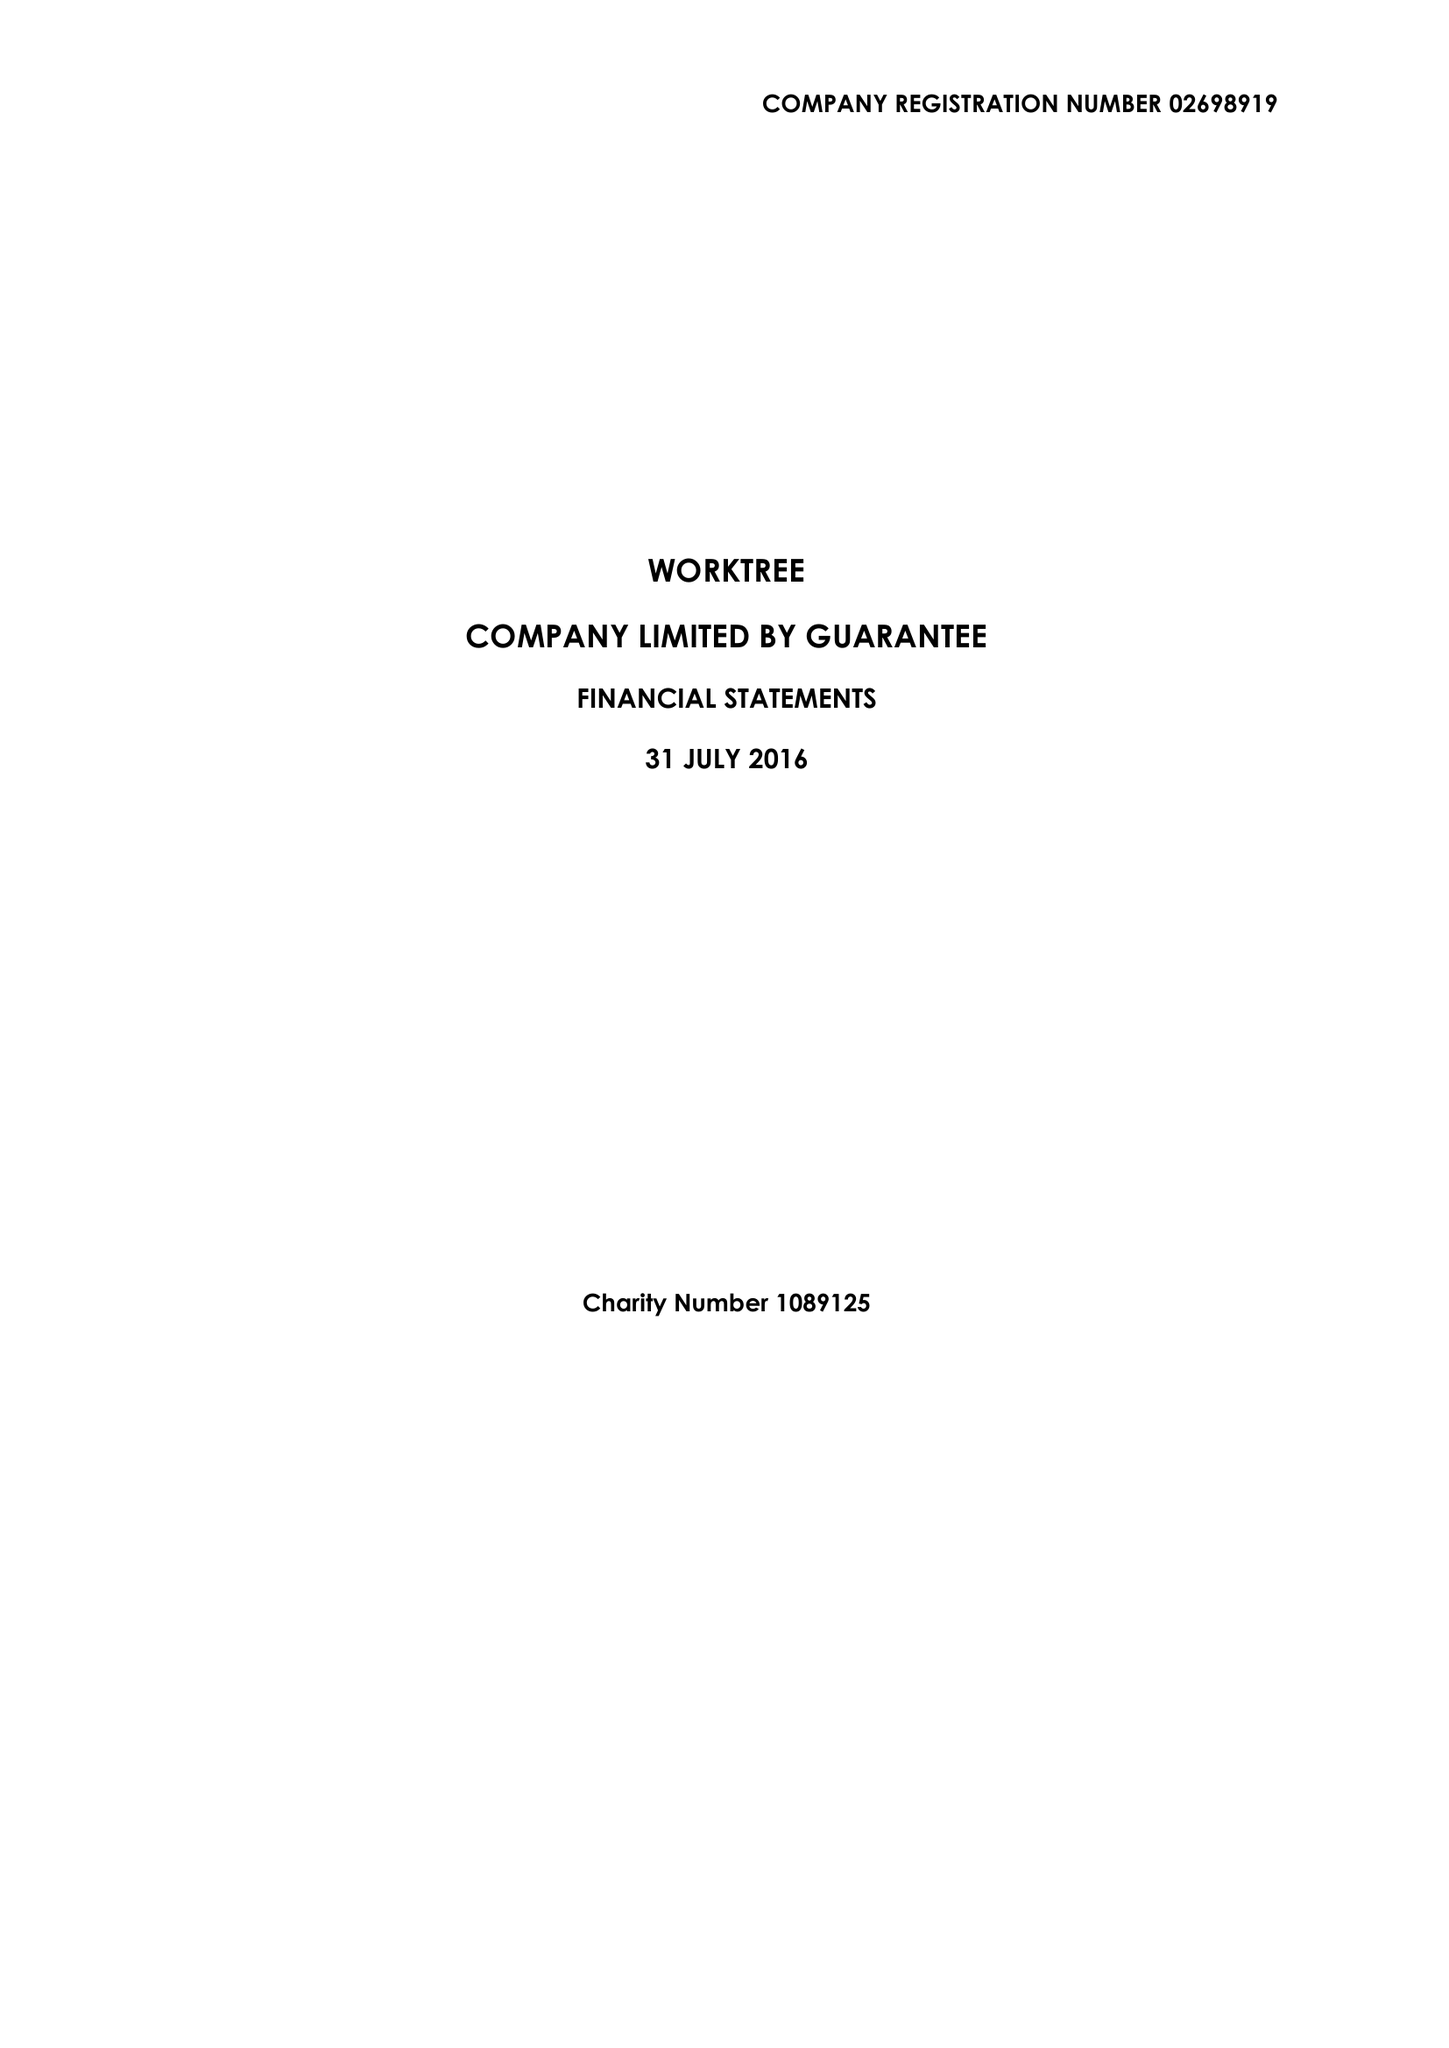What is the value for the income_annually_in_british_pounds?
Answer the question using a single word or phrase. 55626.00 